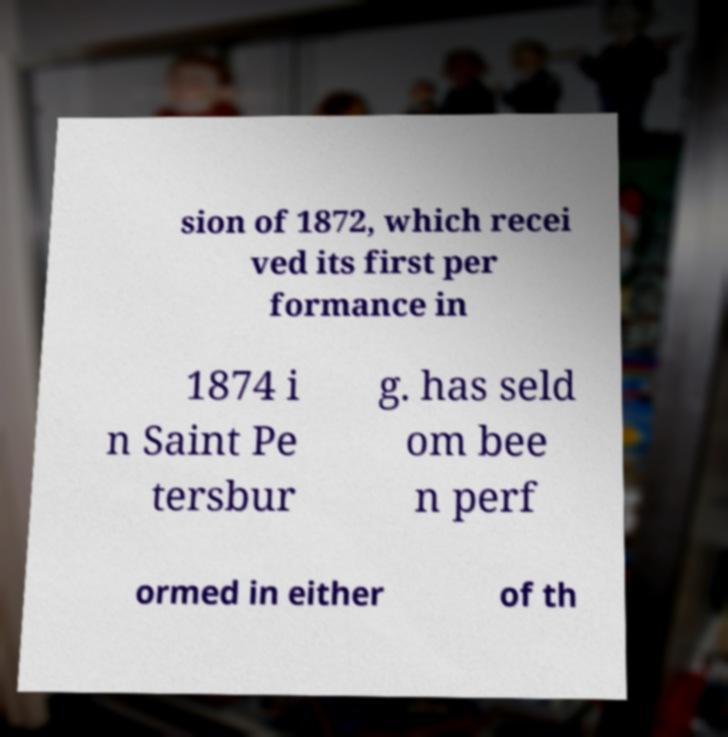What messages or text are displayed in this image? I need them in a readable, typed format. sion of 1872, which recei ved its first per formance in 1874 i n Saint Pe tersbur g. has seld om bee n perf ormed in either of th 